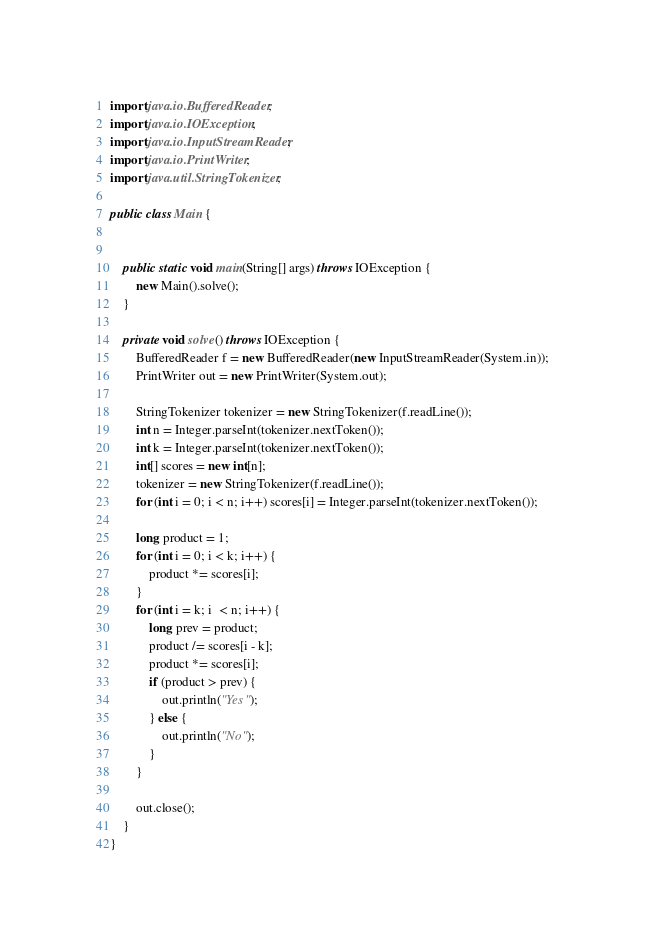Convert code to text. <code><loc_0><loc_0><loc_500><loc_500><_Java_>import java.io.BufferedReader;
import java.io.IOException;
import java.io.InputStreamReader;
import java.io.PrintWriter;
import java.util.StringTokenizer;

public class Main {


    public static void main(String[] args) throws IOException {
        new Main().solve();
    }

    private void solve() throws IOException {
        BufferedReader f = new BufferedReader(new InputStreamReader(System.in));
        PrintWriter out = new PrintWriter(System.out);

        StringTokenizer tokenizer = new StringTokenizer(f.readLine());
        int n = Integer.parseInt(tokenizer.nextToken());
        int k = Integer.parseInt(tokenizer.nextToken());
        int[] scores = new int[n];
        tokenizer = new StringTokenizer(f.readLine());
        for (int i = 0; i < n; i++) scores[i] = Integer.parseInt(tokenizer.nextToken());

        long product = 1;
        for (int i = 0; i < k; i++) {
            product *= scores[i];
        }
        for (int i = k; i  < n; i++) {
            long prev = product;
            product /= scores[i - k];
            product *= scores[i];
            if (product > prev) {
                out.println("Yes");
            } else {
                out.println("No");
            }
        }

        out.close();
    }
}</code> 